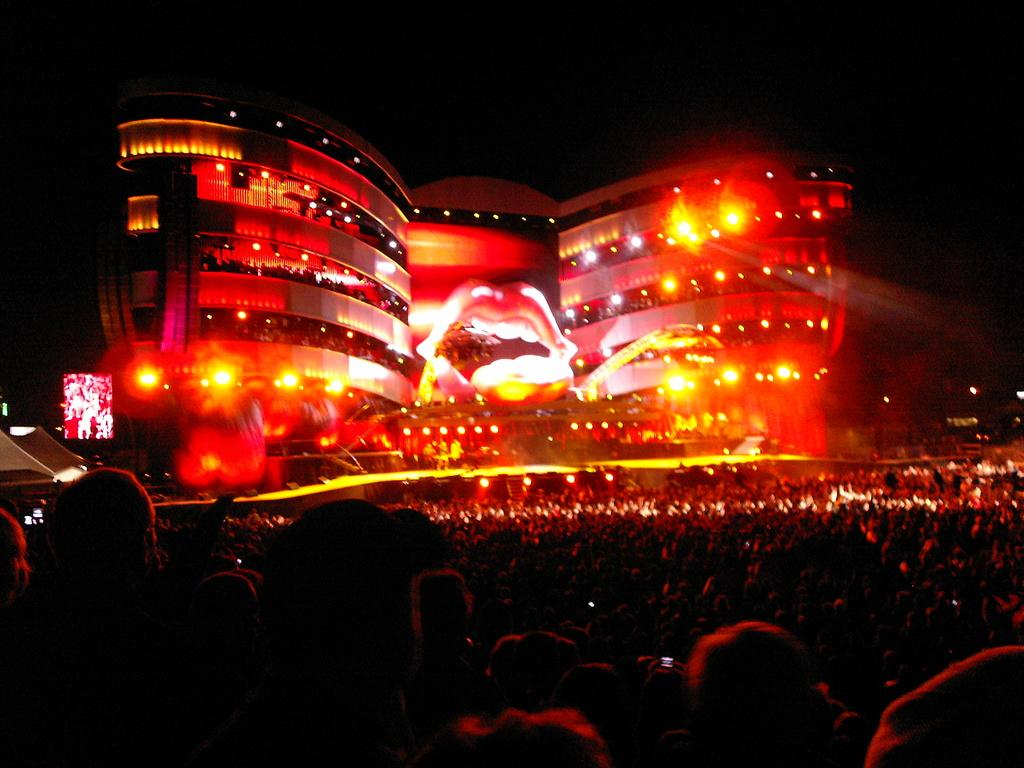What structure is present in the image? There is a building in the image. Who or what can be seen near the building? There is a group of people in the image. What can be seen illuminating the scene in the image? There are lights visible in the image. What device is present in the image that might display information? There is a screen in the image. What color is the background of the image? The background of the image is black. What type of clam is being used as a writing tool by the group of people in the image? There is no clam or writing tool visible in the image; it only features a building, a group of people, lights, a screen, and a black background. 